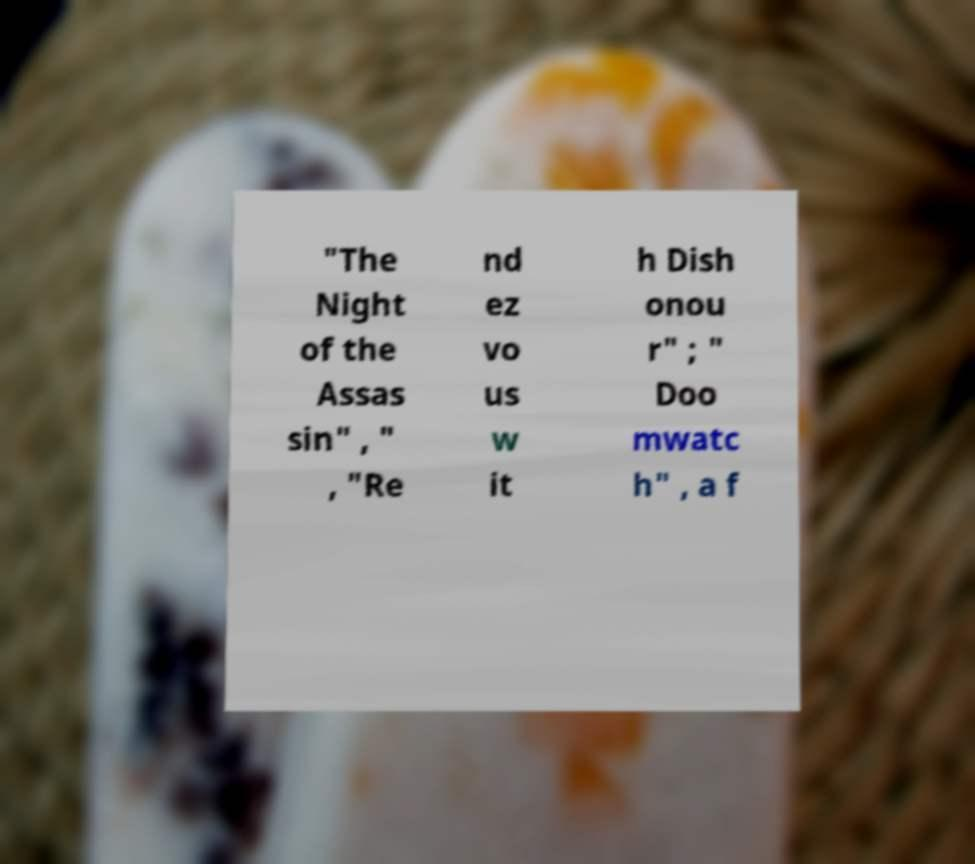Please identify and transcribe the text found in this image. "The Night of the Assas sin" , " , "Re nd ez vo us w it h Dish onou r" ; " Doo mwatc h" , a f 